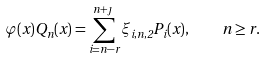<formula> <loc_0><loc_0><loc_500><loc_500>\varphi ( x ) Q _ { n } ( x ) = \sum _ { i = n - r } ^ { n + \jmath } \xi _ { i , n , 2 } P _ { i } ( x ) , \quad n \geq r .</formula> 